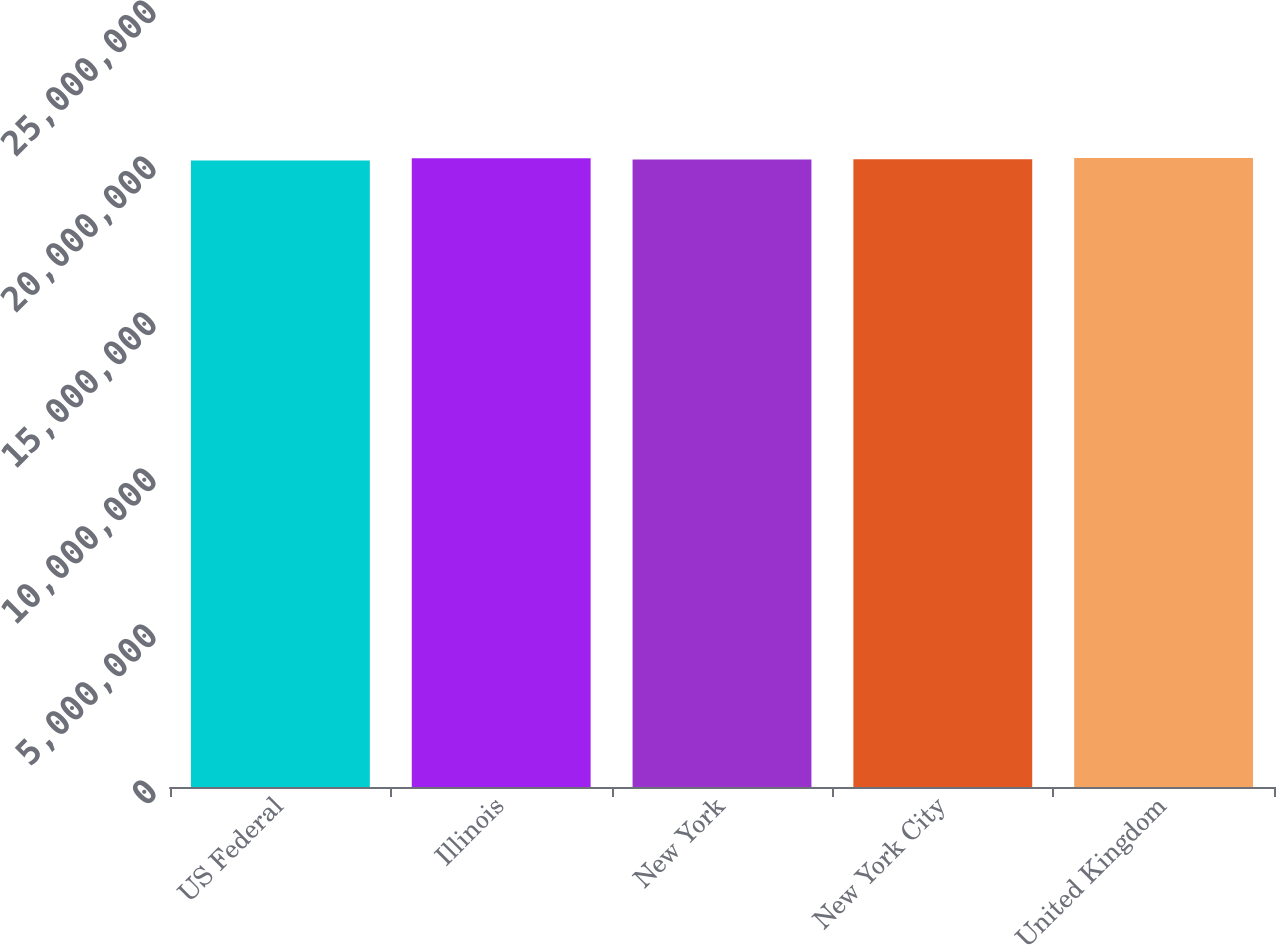<chart> <loc_0><loc_0><loc_500><loc_500><bar_chart><fcel>US Federal<fcel>Illinois<fcel>New York<fcel>New York City<fcel>United Kingdom<nl><fcel>2.0082e+07<fcel>2.0152e+07<fcel>2.0112e+07<fcel>2.012e+07<fcel>2.0162e+07<nl></chart> 